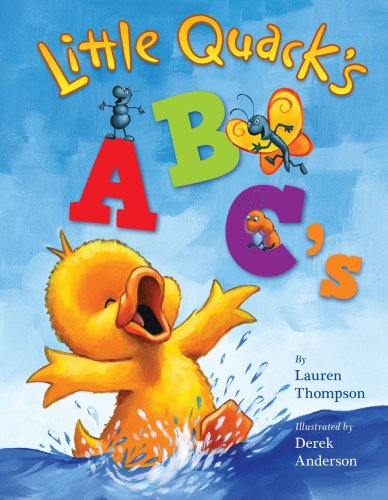Is this a kids book? Yes, indeed! This book is designed especially for kids, featuring engaging illustrations and a playful approach to learning the alphabet through the adventures of Little Quack. 